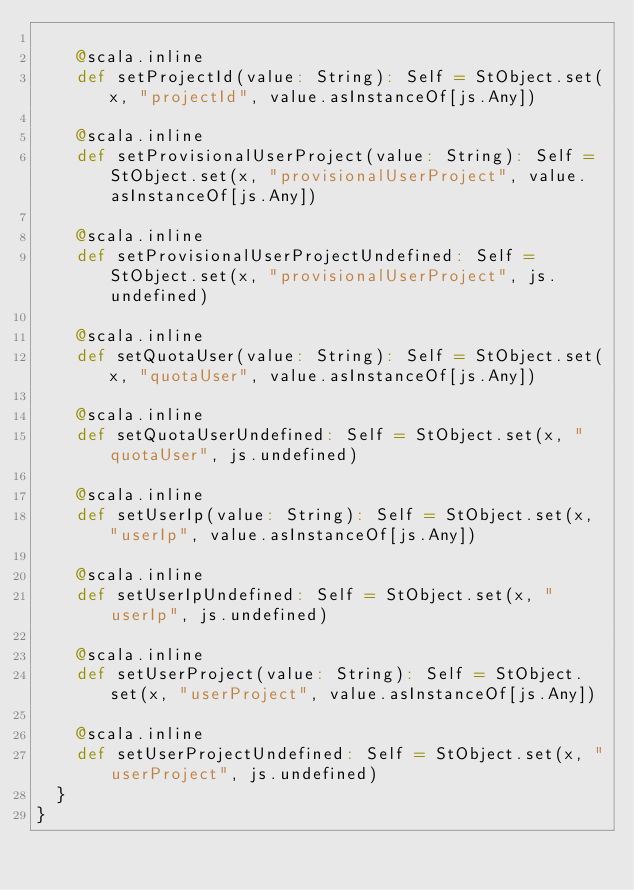<code> <loc_0><loc_0><loc_500><loc_500><_Scala_>    
    @scala.inline
    def setProjectId(value: String): Self = StObject.set(x, "projectId", value.asInstanceOf[js.Any])
    
    @scala.inline
    def setProvisionalUserProject(value: String): Self = StObject.set(x, "provisionalUserProject", value.asInstanceOf[js.Any])
    
    @scala.inline
    def setProvisionalUserProjectUndefined: Self = StObject.set(x, "provisionalUserProject", js.undefined)
    
    @scala.inline
    def setQuotaUser(value: String): Self = StObject.set(x, "quotaUser", value.asInstanceOf[js.Any])
    
    @scala.inline
    def setQuotaUserUndefined: Self = StObject.set(x, "quotaUser", js.undefined)
    
    @scala.inline
    def setUserIp(value: String): Self = StObject.set(x, "userIp", value.asInstanceOf[js.Any])
    
    @scala.inline
    def setUserIpUndefined: Self = StObject.set(x, "userIp", js.undefined)
    
    @scala.inline
    def setUserProject(value: String): Self = StObject.set(x, "userProject", value.asInstanceOf[js.Any])
    
    @scala.inline
    def setUserProjectUndefined: Self = StObject.set(x, "userProject", js.undefined)
  }
}
</code> 